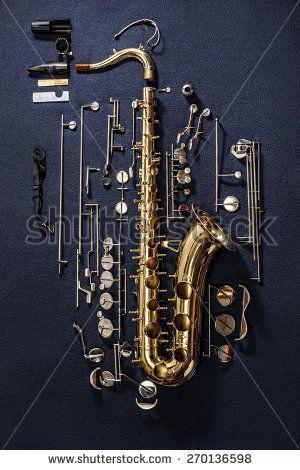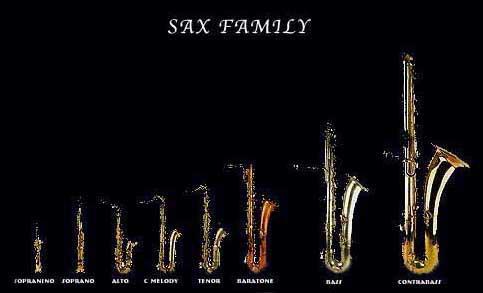The first image is the image on the left, the second image is the image on the right. For the images shown, is this caption "There are less than five musical instruments." true? Answer yes or no. No. 